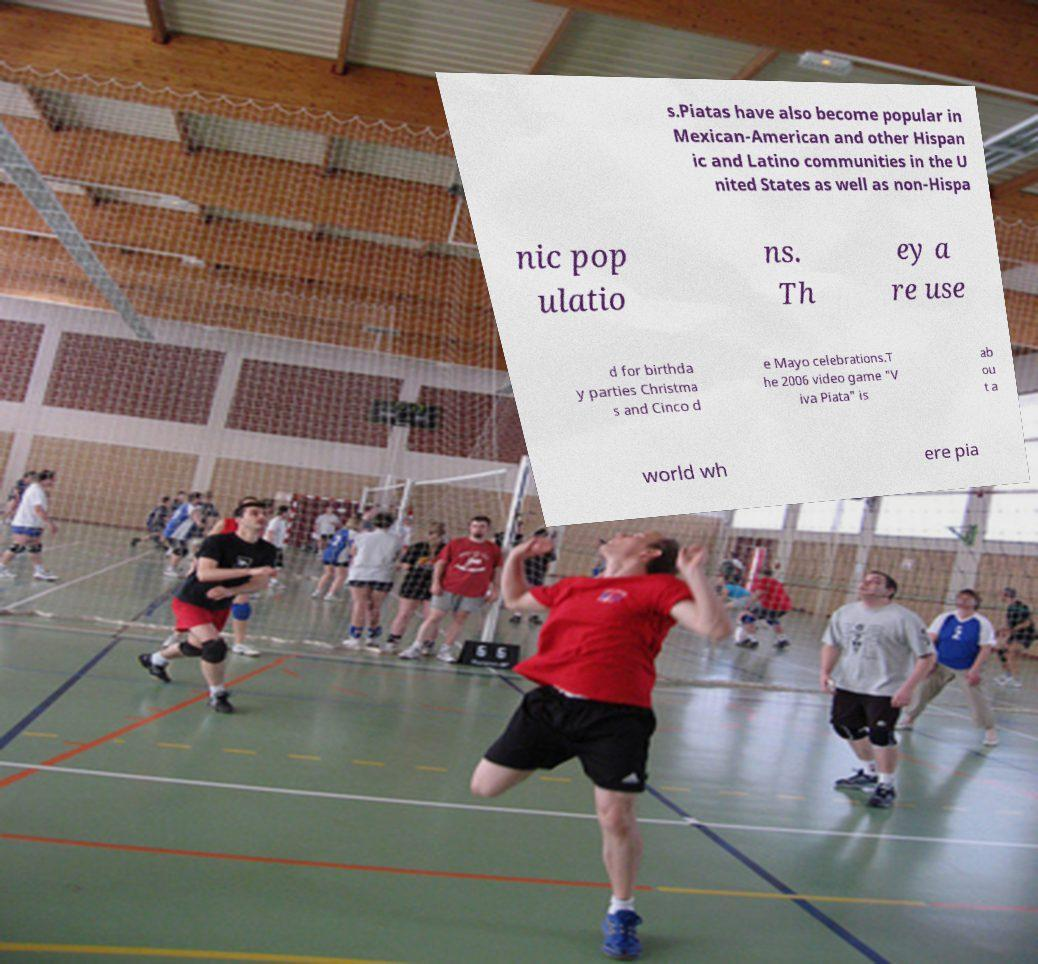There's text embedded in this image that I need extracted. Can you transcribe it verbatim? s.Piatas have also become popular in Mexican-American and other Hispan ic and Latino communities in the U nited States as well as non-Hispa nic pop ulatio ns. Th ey a re use d for birthda y parties Christma s and Cinco d e Mayo celebrations.T he 2006 video game "V iva Piata" is ab ou t a world wh ere pia 